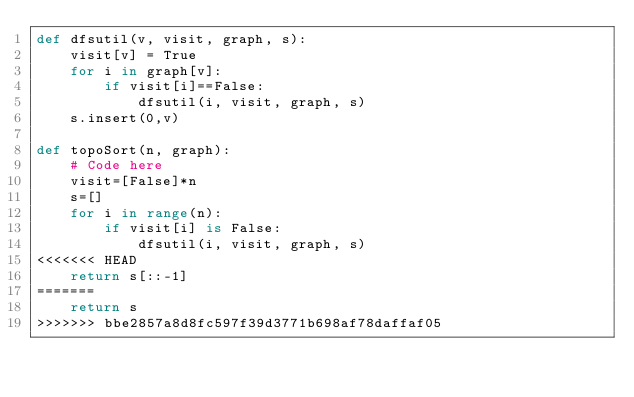<code> <loc_0><loc_0><loc_500><loc_500><_Python_>def dfsutil(v, visit, graph, s):
    visit[v] = True
    for i in graph[v]:
        if visit[i]==False:
            dfsutil(i, visit, graph, s)
    s.insert(0,v)
    
def topoSort(n, graph):
    # Code here
    visit=[False]*n
    s=[]
    for i in range(n):
        if visit[i] is False:
            dfsutil(i, visit, graph, s)
<<<<<<< HEAD
    return s[::-1]
=======
    return s
>>>>>>> bbe2857a8d8fc597f39d3771b698af78daffaf05
</code> 